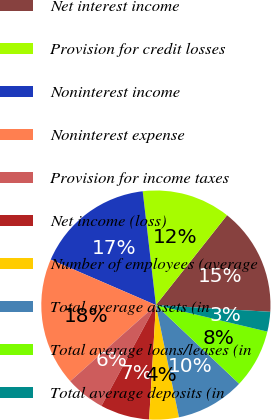Convert chart to OTSL. <chart><loc_0><loc_0><loc_500><loc_500><pie_chart><fcel>Net interest income<fcel>Provision for credit losses<fcel>Noninterest income<fcel>Noninterest expense<fcel>Provision for income taxes<fcel>Net income (loss)<fcel>Number of employees (average<fcel>Total average assets (in<fcel>Total average loans/leases (in<fcel>Total average deposits (in<nl><fcel>15.28%<fcel>12.5%<fcel>16.67%<fcel>18.06%<fcel>5.56%<fcel>6.94%<fcel>4.17%<fcel>9.72%<fcel>8.33%<fcel>2.78%<nl></chart> 